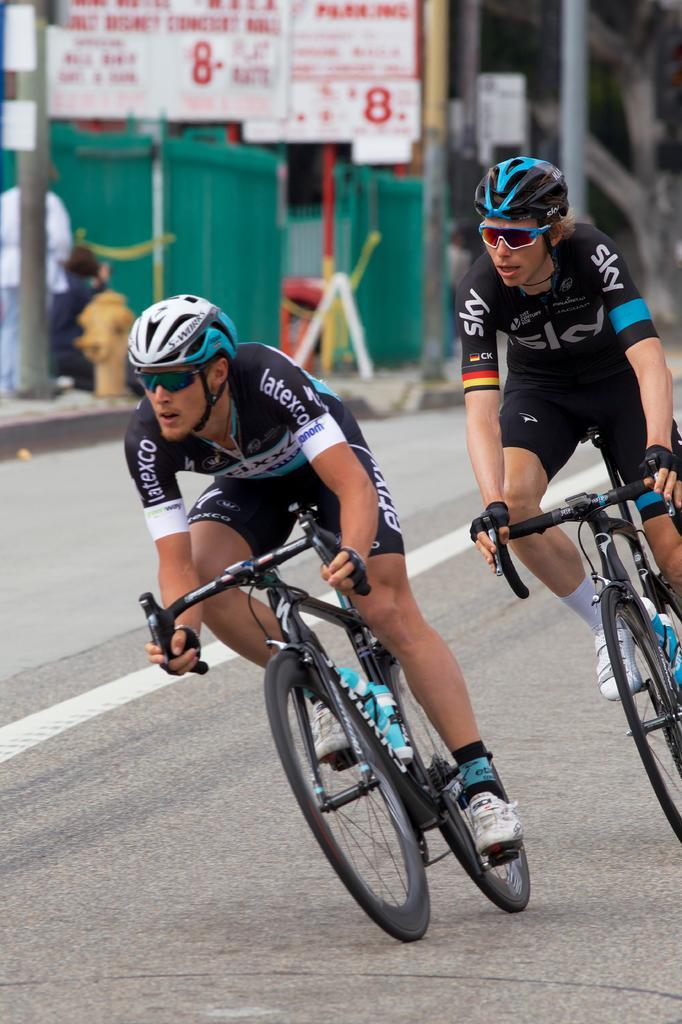Can you describe this image briefly? In this picture we can see two people riding bicycles on the road and in the background we can see few people, boards, poles and some objects. 